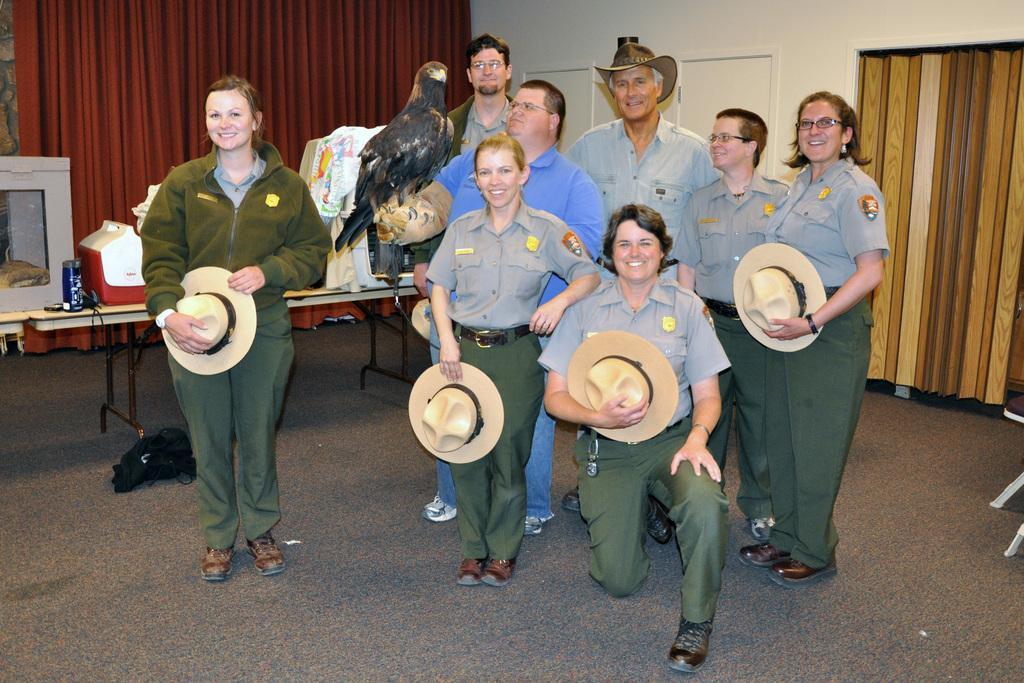Describe this image in one or two sentences. This image is clicked in a room. There are eight persons, one person standing aside and remaining are standing in group. A person in the center is in a squatting position and holding a hat, there are two persons besides her, holding hats. There is a man, he is wearing a blue t shirt and holding a eagle. In the left side there is a woman, she is wearing a green jacket and holding a hat, behind her there is a table, on the table there is a oven, can and a tool box. In the background there is a curtain and a wall. 